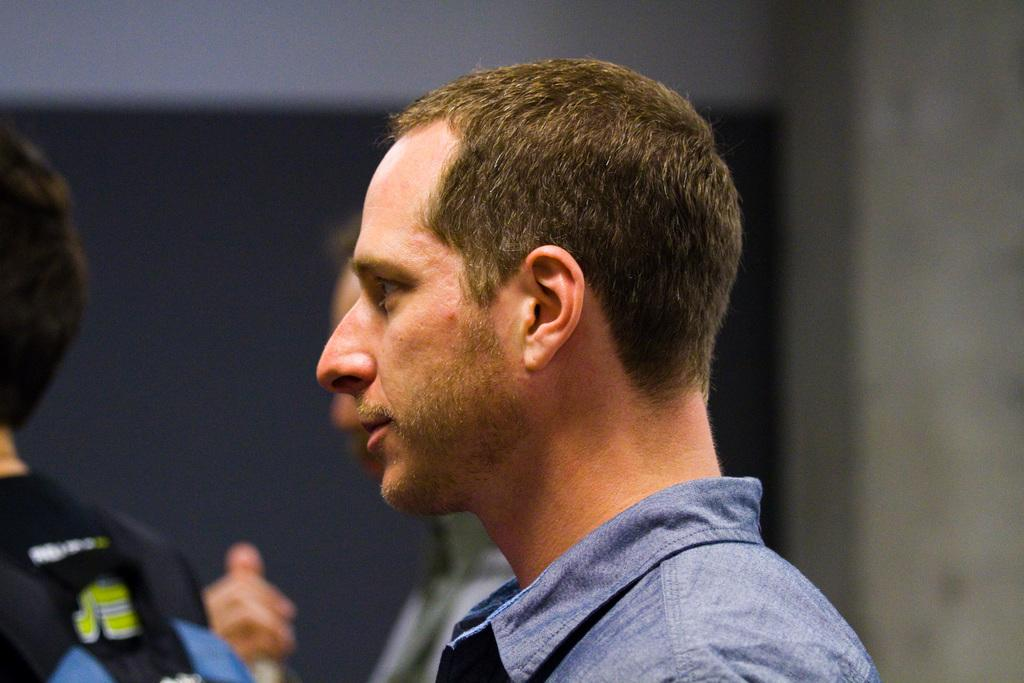What is the man in the blue shirt wearing in the image? The man in the blue shirt is wearing a blue shirt in the image. What is the man in the blue shirt doing in the image? The man in the blue shirt is standing in the image. How many other men are standing in the image? There are two other men standing in the image. What is the position of the third man in relation to the other two men? The third man is standing in front of the other two men in the image. What can be seen in the background of the image? There is a wall visible in the background of the image. What is the profit of the ice that the men are selling in the image? There is no ice or selling activity present in the image; it features three men standing together. 